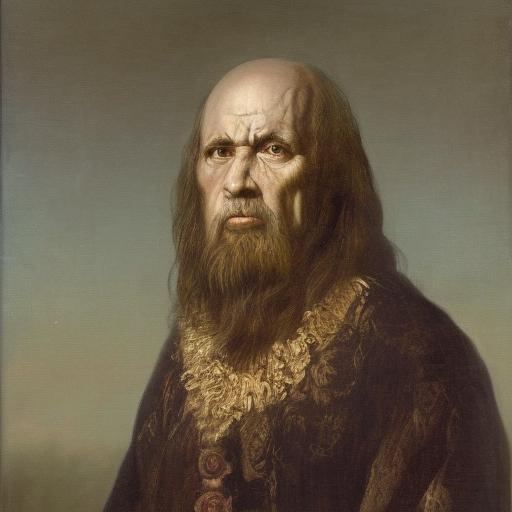Is the lighting in the image well-balanced? While the overall composition is well-executed, the lighting on the subject's face appears somewhat flat, lacking dynamic contrast and depth that would enhance the three-dimensional appearance of facial features. 